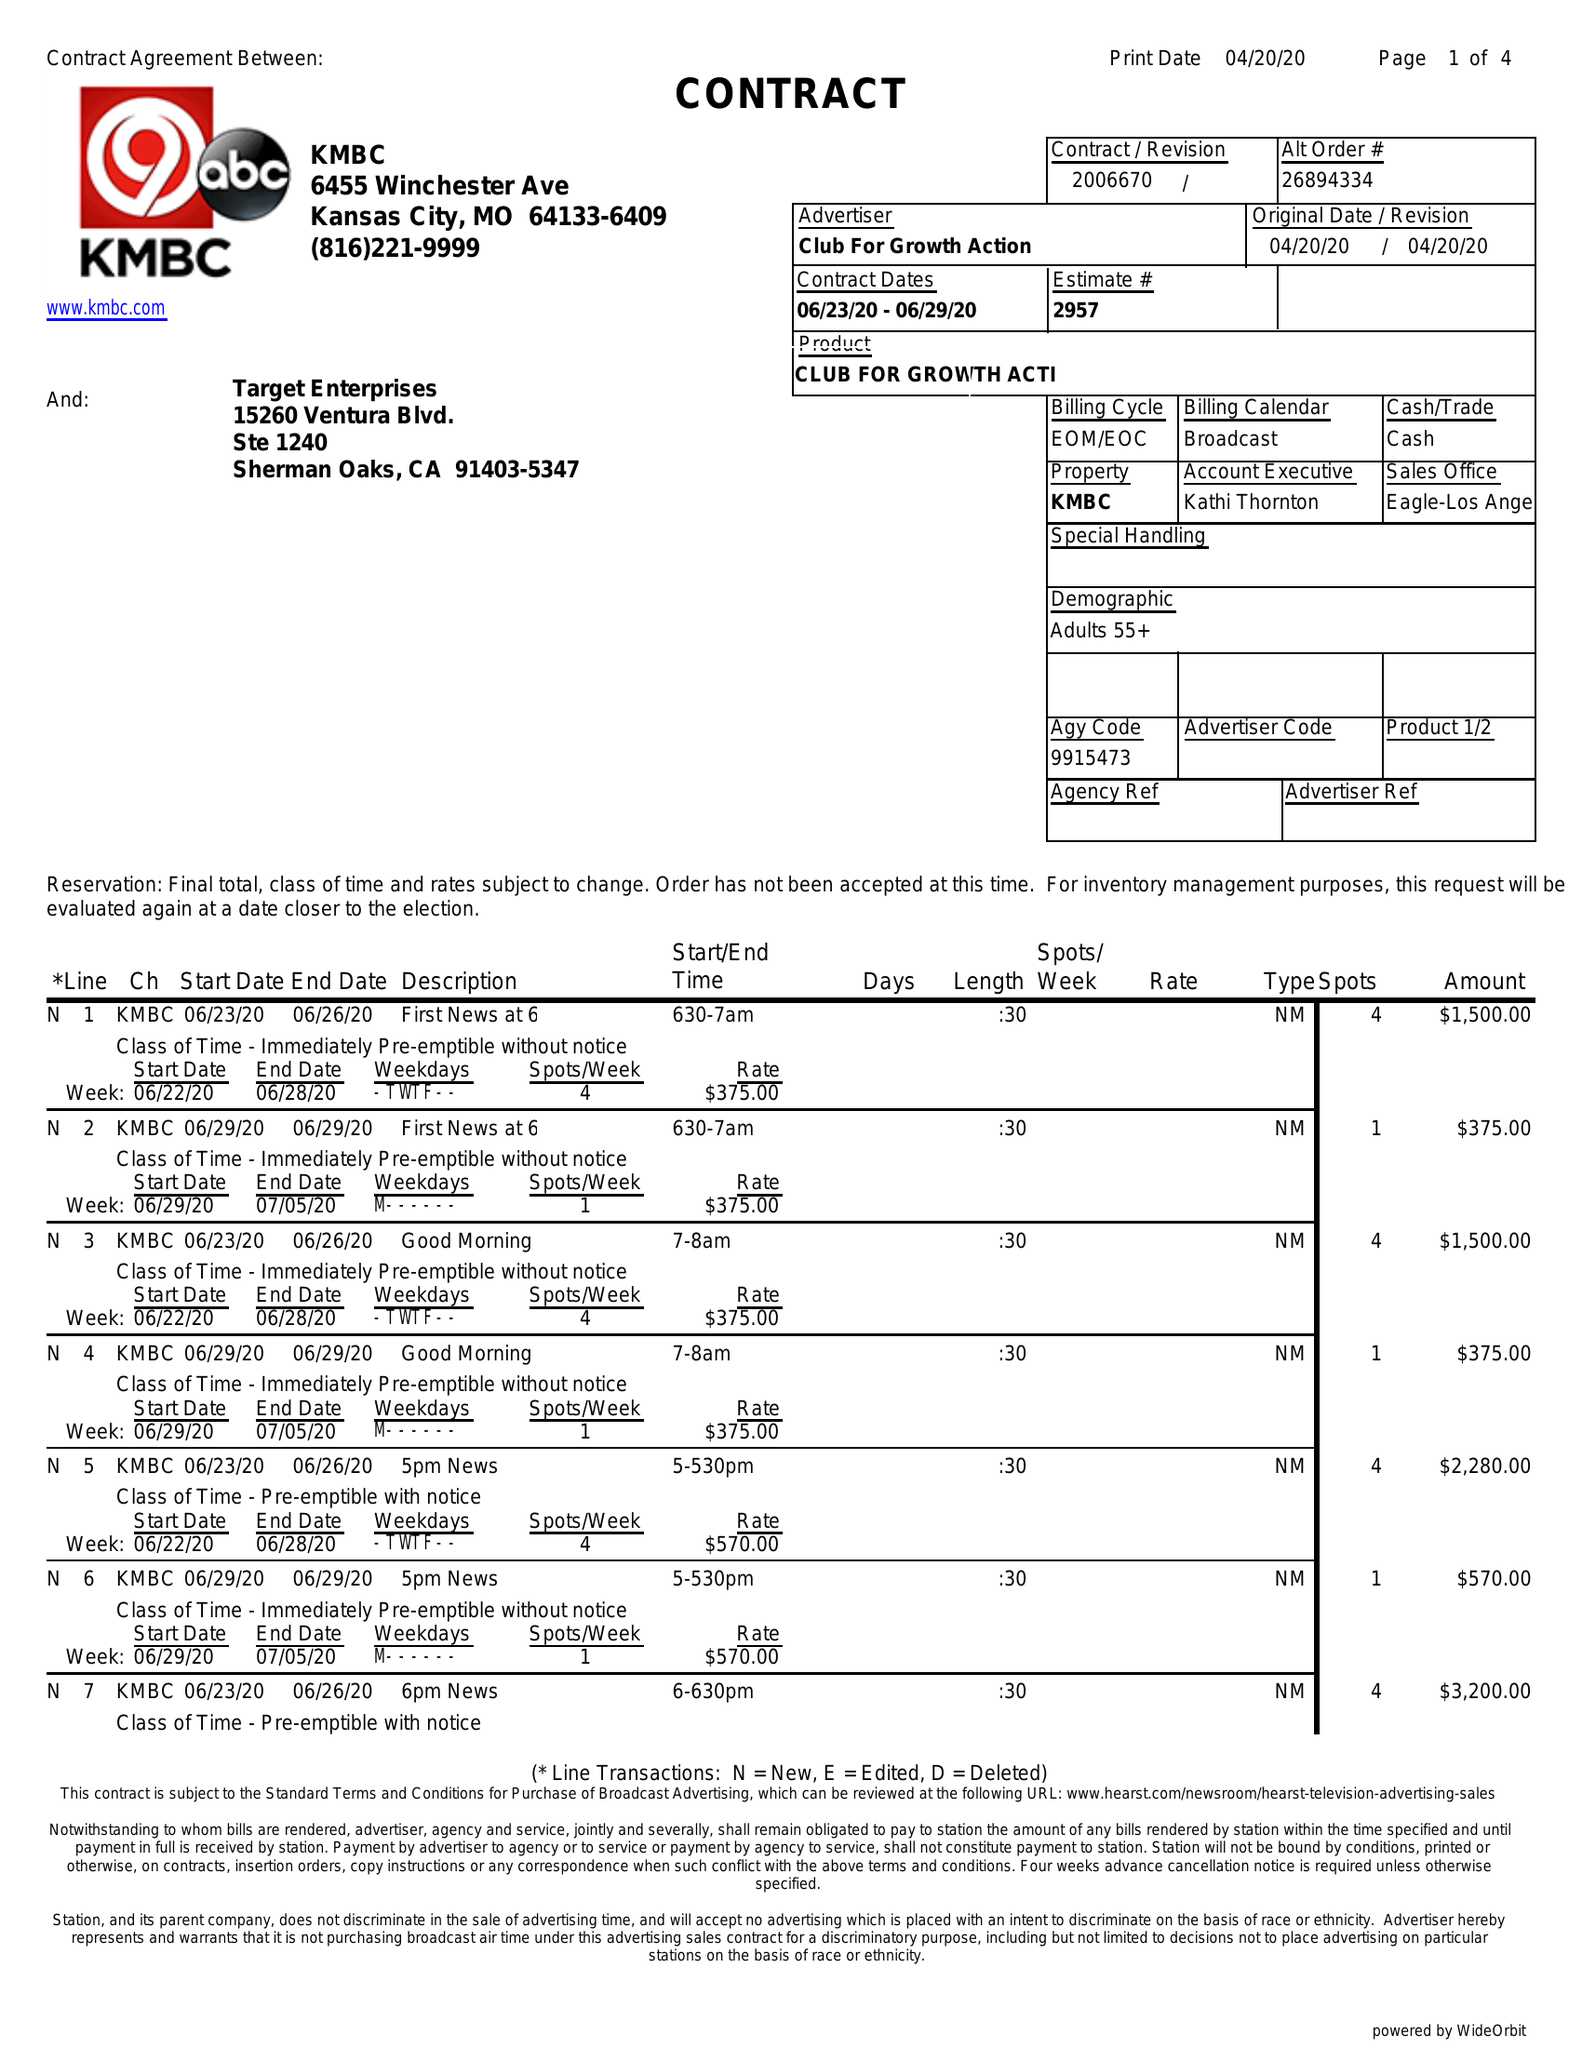What is the value for the contract_num?
Answer the question using a single word or phrase. 2006670 